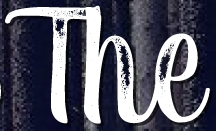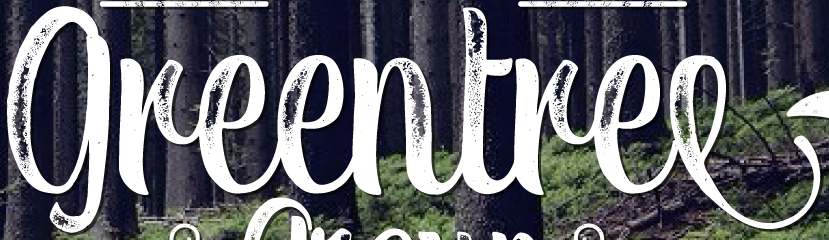Read the text content from these images in order, separated by a semicolon. The; greentree 